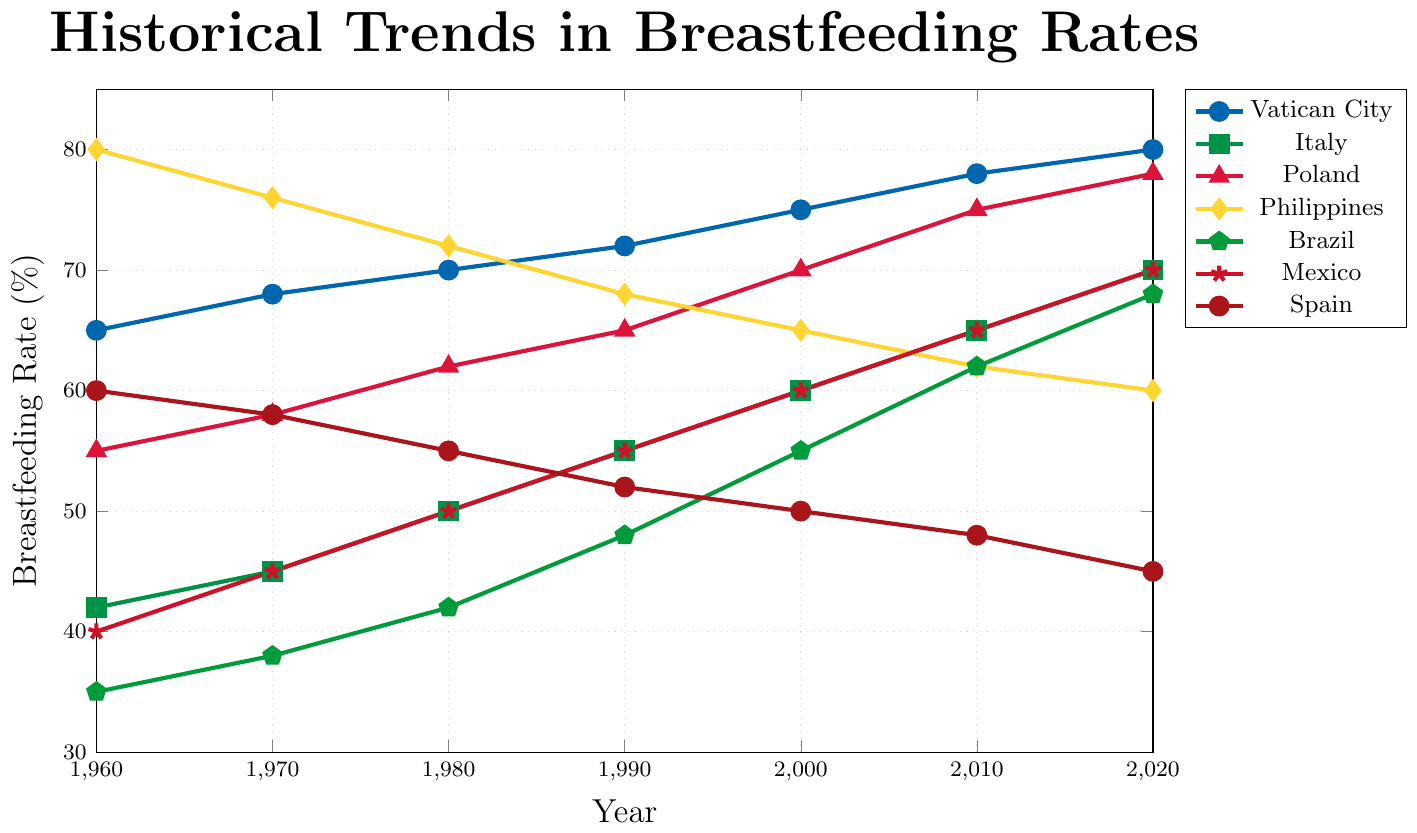What's the trend of breastfeeding rates in Vatican City from 1960 to 2020? To determine the trend, observe the points associated with Vatican City on the plot. The breastfeeding rates in Vatican City increase gradually over the years from 65% in 1960 to 80% in 2020.
Answer: Increasing Which country had the highest breastfeeding rate in 1960? By looking at the year 1960 on the x-axis and comparing the y-values, the Philippines had the highest breastfeeding rate at 80%.
Answer: Philippines How does the trend in Spain's breastfeeding rates compare to Brazil's? Spain's breastfeeding rates decline from 60% in 1960 to 45% in 2020, while Brazil's rates show an increasing trend from 35% in 1960 to 68% in 2020.
Answer: Spain declines, Brazil increases Between 2000 and 2020, which country had the largest increase in breastfeeding rates? Analyzing the data points between 2000 and 2020 for each country, the Philippines had a slight decrease, Spain decreased, and other countries increased. Poland went from 70% to 78%, the largest increase of 8%.
Answer: Poland What is the average breastfeeding rate for Italy across all the years presented? Summing up Italy's rates (42+45+50+55+60+65+70) gives 387. Dividing by the number of data points (7) results in an average of 55.3%.
Answer: 55.3% Which country showed a consistently increasing trend in breastfeeding rates from 1960 to 2020? A consistently increasing trend means there is no year where the rate decreases compared to the previous year. Observing the plots, Vatican City, Italy, Poland, and Mexico all show a consistently increasing trend.
Answer: Vatican City, Italy, Poland, Mexico What is the difference in breastfeeding rate between Brazil and Mexico in 2010? Locate the 2010 points for Brazil (62%) and Mexico (65%). Subtracting the values gives: 65% - 62% = 3%.
Answer: 3% Which country had a higher breastfeeding rate in 1980, Poland or Spain? Looking at the year 1980, Poland’s rate is 62%, while Spain’s rate is 55%. Therefore, Poland had a higher rate.
Answer: Poland What is the sum of breastfeeding rates of Poland and the Philippines in 2020? Adding the breastfeeding rates for Poland (78%) and the Philippines (60%) in 2020 results in 78 + 60 = 138%.
Answer: 138% How does the breastfeeding rate in 2000 for the Vatican City compare to that in 1980 for the Philippines? The rate in Vatican City in 2000 is 75%, and for the Philippines in 1980 it is 72%. Therefore, the Vatican City's rate in 2000 is higher.
Answer: Vatican City is higher 